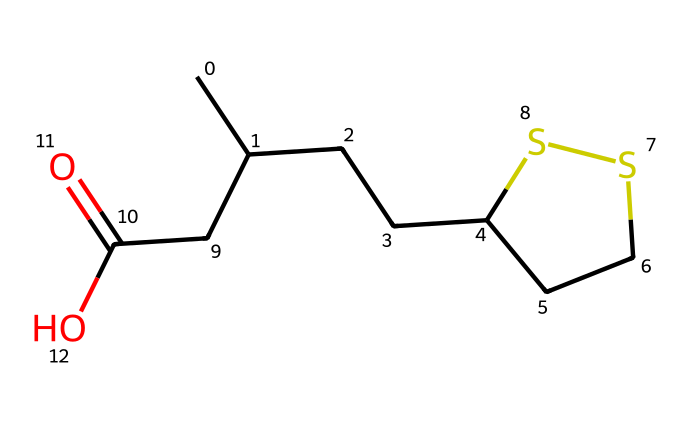What is the name of this compound? The SMILES representation indicates the structure of lipoic acid, which is a well-known organosulfur compound and antioxidant.
Answer: lipoic acid How many carbon atoms are present? Analyzing the SMILES string, there are 8 carbon atoms as seen in the structure indicated by the 'C' count.
Answer: 8 What type of functional group is present in this compound? The presence of 'CC(=O)O' in the SMILES suggests that there is a carboxylic acid functional group present in the structure.
Answer: carboxylic acid How many sulfur atoms does lipoic acid have? The 'S' in the SMILES string indicates there are two sulfur atoms connected in a ring, typical for lipoic acid's structure.
Answer: 2 Is lipoic acid polar or non-polar? The presence of functional groups like the carboxylic acid introduces polarity, making the compound polar overall.
Answer: polar What role does lipoic acid play in human health? Lipoic acid is primarily known for its antioxidant properties, helping to neutralize free radicals in the body.
Answer: antioxidant What type of compound is lipoic acid classified as? As it contains carbon, hydrogen, and sulfur, lipoic acid is classified as an organosulfur compound.
Answer: organosulfur compound 